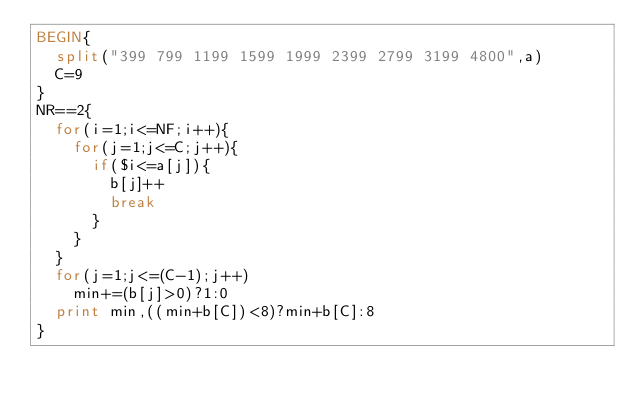<code> <loc_0><loc_0><loc_500><loc_500><_Awk_>BEGIN{
  split("399 799 1199 1599 1999 2399 2799 3199 4800",a)
  C=9
}
NR==2{
  for(i=1;i<=NF;i++){
    for(j=1;j<=C;j++){
      if($i<=a[j]){
        b[j]++
        break
      }
    }
  }
  for(j=1;j<=(C-1);j++)
    min+=(b[j]>0)?1:0
  print min,((min+b[C])<8)?min+b[C]:8
}</code> 